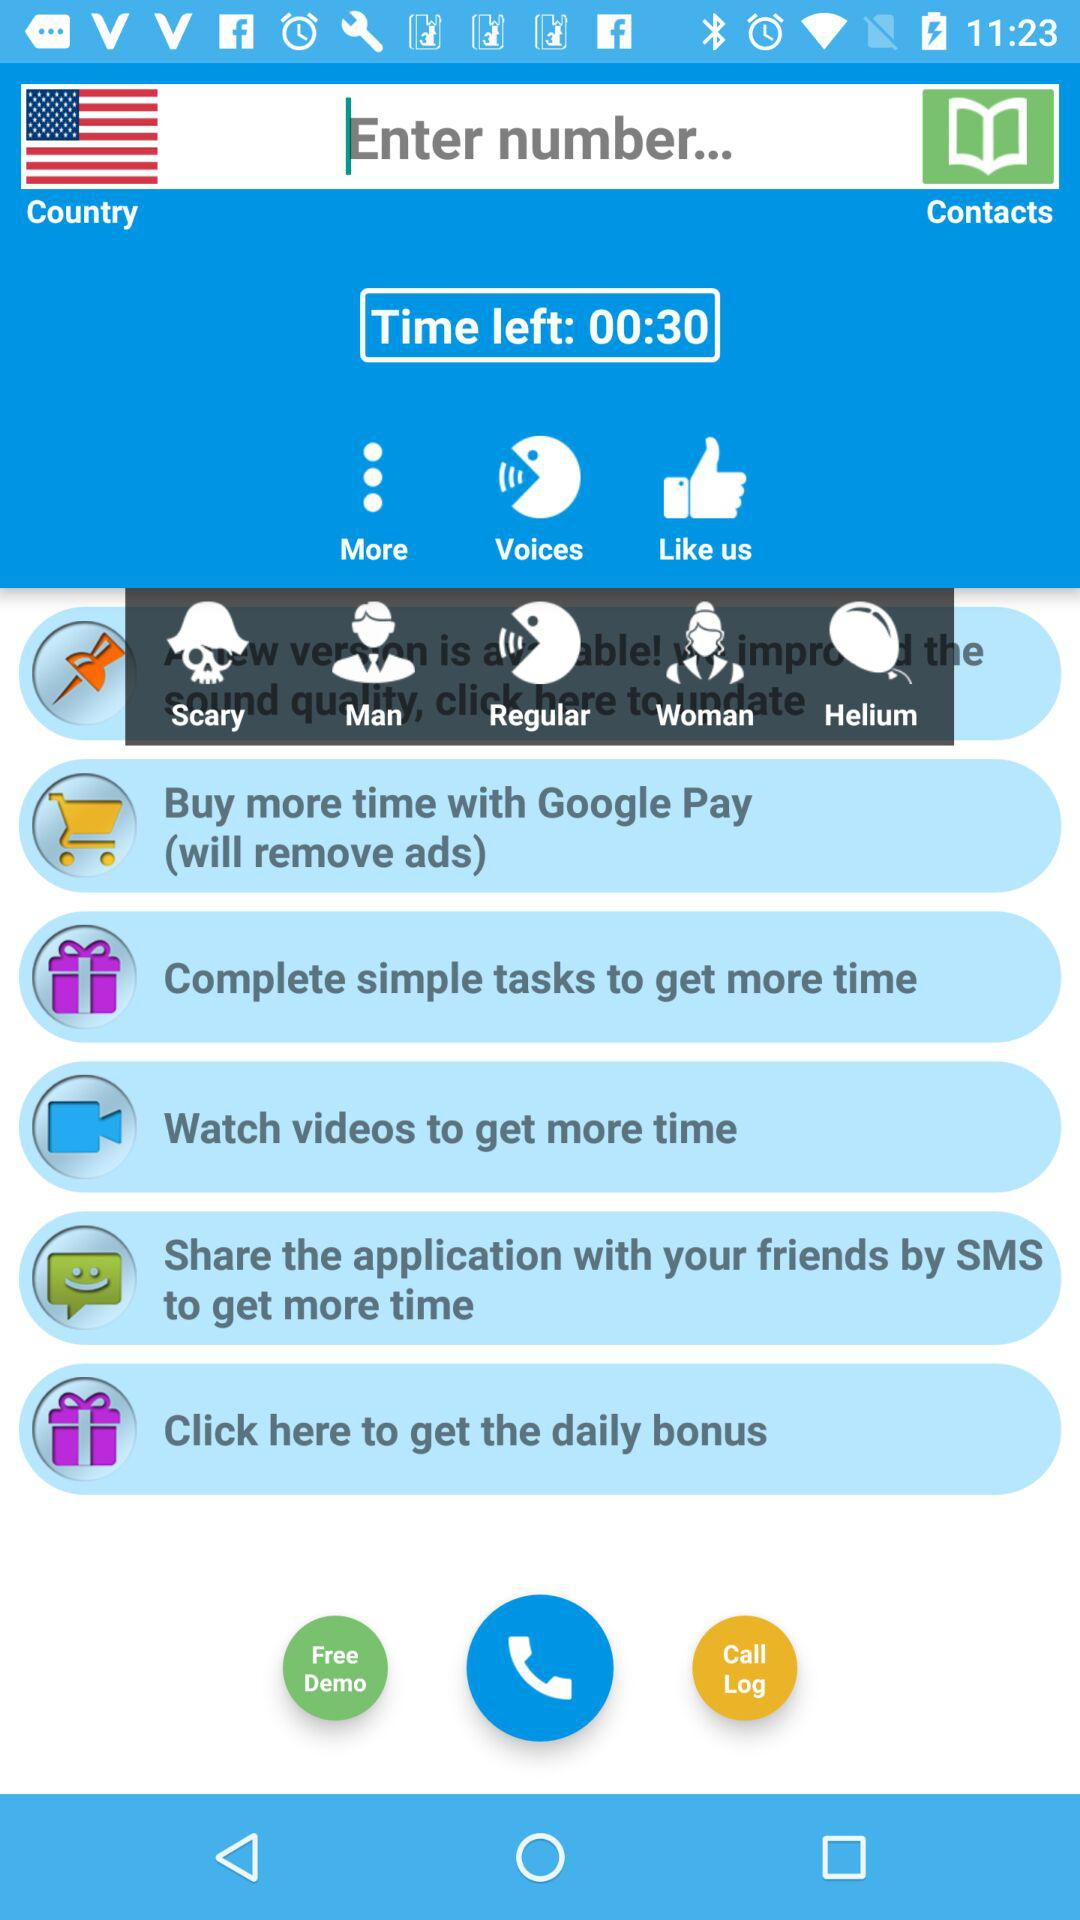Which country's flag is shown on the screen?
When the provided information is insufficient, respond with <no answer>. <no answer> 